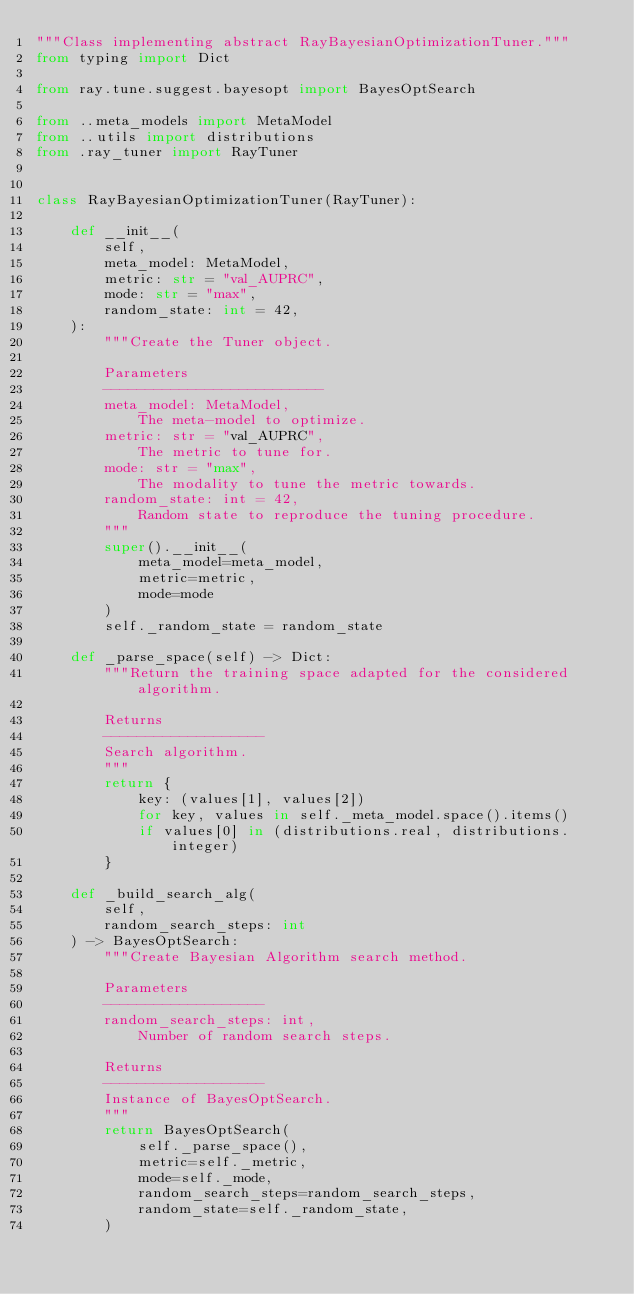<code> <loc_0><loc_0><loc_500><loc_500><_Python_>"""Class implementing abstract RayBayesianOptimizationTuner."""
from typing import Dict

from ray.tune.suggest.bayesopt import BayesOptSearch

from ..meta_models import MetaModel
from ..utils import distributions
from .ray_tuner import RayTuner


class RayBayesianOptimizationTuner(RayTuner):

    def __init__(
        self,
        meta_model: MetaModel,
        metric: str = "val_AUPRC",
        mode: str = "max",
        random_state: int = 42,
    ):
        """Create the Tuner object.

        Parameters
        --------------------------
        meta_model: MetaModel,
            The meta-model to optimize.
        metric: str = "val_AUPRC",
            The metric to tune for.
        mode: str = "max",
            The modality to tune the metric towards.
        random_state: int = 42,
            Random state to reproduce the tuning procedure.
        """
        super().__init__(
            meta_model=meta_model,
            metric=metric,
            mode=mode
        )
        self._random_state = random_state

    def _parse_space(self) -> Dict:
        """Return the training space adapted for the considered algorithm.

        Returns
        -------------------
        Search algorithm.
        """
        return {
            key: (values[1], values[2])
            for key, values in self._meta_model.space().items()
            if values[0] in (distributions.real, distributions.integer)
        }

    def _build_search_alg(
        self,
        random_search_steps: int
    ) -> BayesOptSearch:
        """Create Bayesian Algorithm search method.

        Parameters
        -------------------
        random_search_steps: int,
            Number of random search steps.

        Returns
        -------------------
        Instance of BayesOptSearch. 
        """
        return BayesOptSearch(
            self._parse_space(),
            metric=self._metric,
            mode=self._mode,
            random_search_steps=random_search_steps,
            random_state=self._random_state,
        )
</code> 